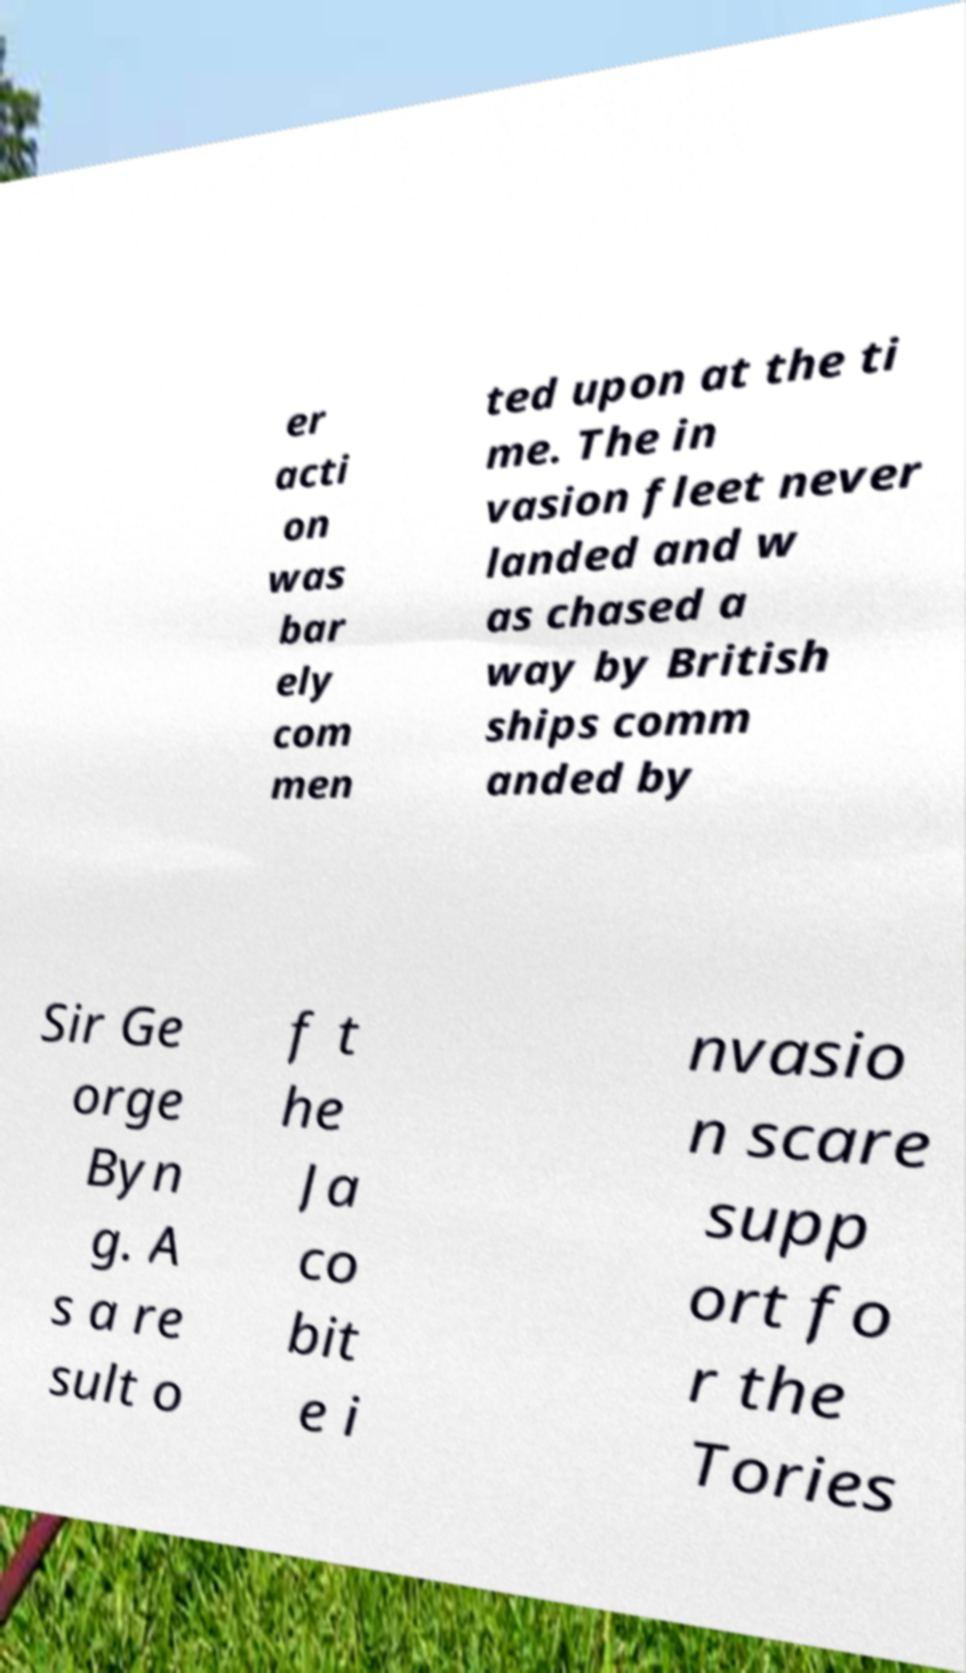Can you read and provide the text displayed in the image?This photo seems to have some interesting text. Can you extract and type it out for me? er acti on was bar ely com men ted upon at the ti me. The in vasion fleet never landed and w as chased a way by British ships comm anded by Sir Ge orge Byn g. A s a re sult o f t he Ja co bit e i nvasio n scare supp ort fo r the Tories 